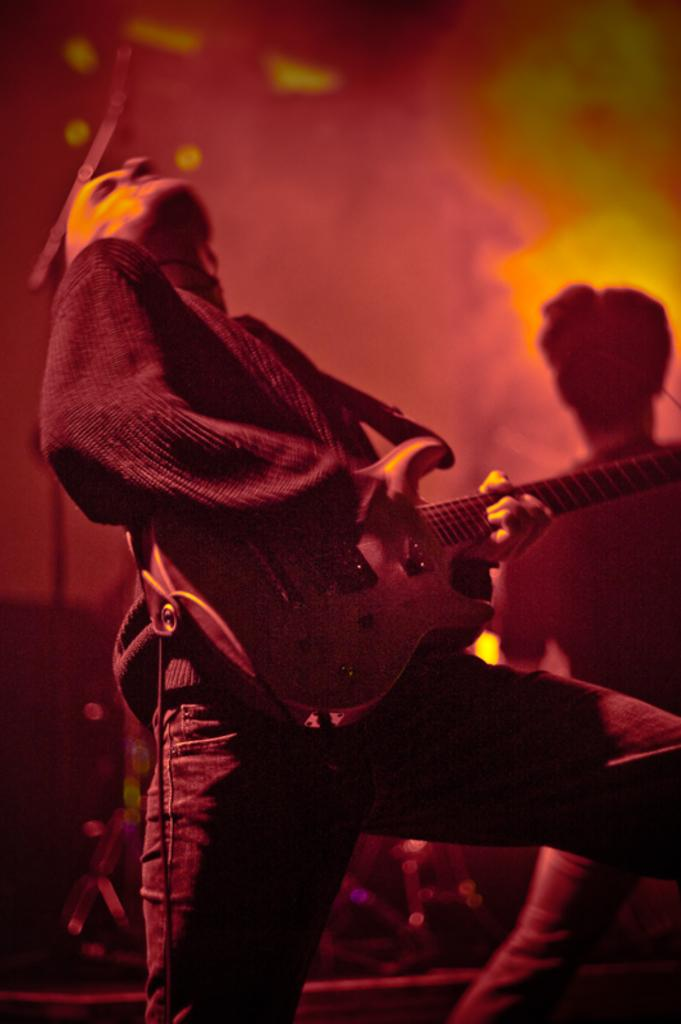What is the main subject of the image? There is a person in the image. What is the person holding in his hands? The person is holding a guitar in his hands. Can you tell me how many people are smiling in the image? The provided facts do not mention anyone smiling in the image. --- 